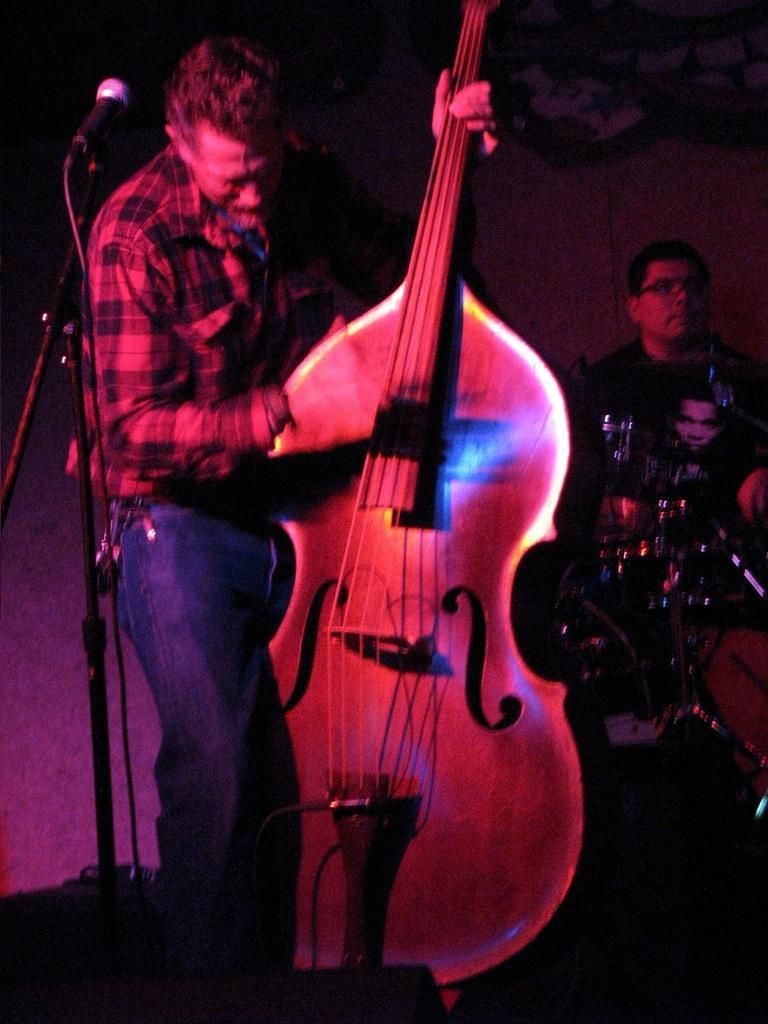How would you summarize this image in a sentence or two? In this picture i could see a person holding a guitar in his hands and standing in front of the mic, in the background i could see a person hitting the drums. 